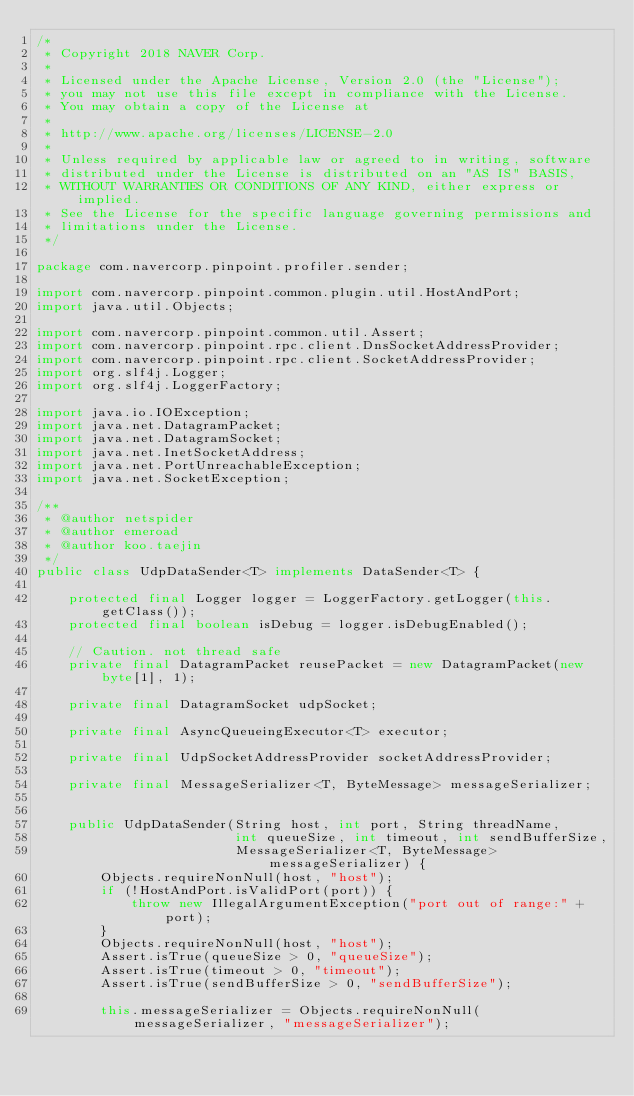Convert code to text. <code><loc_0><loc_0><loc_500><loc_500><_Java_>/*
 * Copyright 2018 NAVER Corp.
 *
 * Licensed under the Apache License, Version 2.0 (the "License");
 * you may not use this file except in compliance with the License.
 * You may obtain a copy of the License at
 *
 * http://www.apache.org/licenses/LICENSE-2.0
 *
 * Unless required by applicable law or agreed to in writing, software
 * distributed under the License is distributed on an "AS IS" BASIS,
 * WITHOUT WARRANTIES OR CONDITIONS OF ANY KIND, either express or implied.
 * See the License for the specific language governing permissions and
 * limitations under the License.
 */

package com.navercorp.pinpoint.profiler.sender;

import com.navercorp.pinpoint.common.plugin.util.HostAndPort;
import java.util.Objects;

import com.navercorp.pinpoint.common.util.Assert;
import com.navercorp.pinpoint.rpc.client.DnsSocketAddressProvider;
import com.navercorp.pinpoint.rpc.client.SocketAddressProvider;
import org.slf4j.Logger;
import org.slf4j.LoggerFactory;

import java.io.IOException;
import java.net.DatagramPacket;
import java.net.DatagramSocket;
import java.net.InetSocketAddress;
import java.net.PortUnreachableException;
import java.net.SocketException;

/**
 * @author netspider
 * @author emeroad
 * @author koo.taejin
 */
public class UdpDataSender<T> implements DataSender<T> {

    protected final Logger logger = LoggerFactory.getLogger(this.getClass());
    protected final boolean isDebug = logger.isDebugEnabled();

    // Caution. not thread safe
    private final DatagramPacket reusePacket = new DatagramPacket(new byte[1], 1);

    private final DatagramSocket udpSocket;

    private final AsyncQueueingExecutor<T> executor;

    private final UdpSocketAddressProvider socketAddressProvider;

    private final MessageSerializer<T, ByteMessage> messageSerializer;


    public UdpDataSender(String host, int port, String threadName,
                         int queueSize, int timeout, int sendBufferSize,
                         MessageSerializer<T, ByteMessage> messageSerializer) {
        Objects.requireNonNull(host, "host");
        if (!HostAndPort.isValidPort(port)) {
            throw new IllegalArgumentException("port out of range:" + port);
        }
        Objects.requireNonNull(host, "host");
        Assert.isTrue(queueSize > 0, "queueSize");
        Assert.isTrue(timeout > 0, "timeout");
        Assert.isTrue(sendBufferSize > 0, "sendBufferSize");

        this.messageSerializer = Objects.requireNonNull(messageSerializer, "messageSerializer");
</code> 